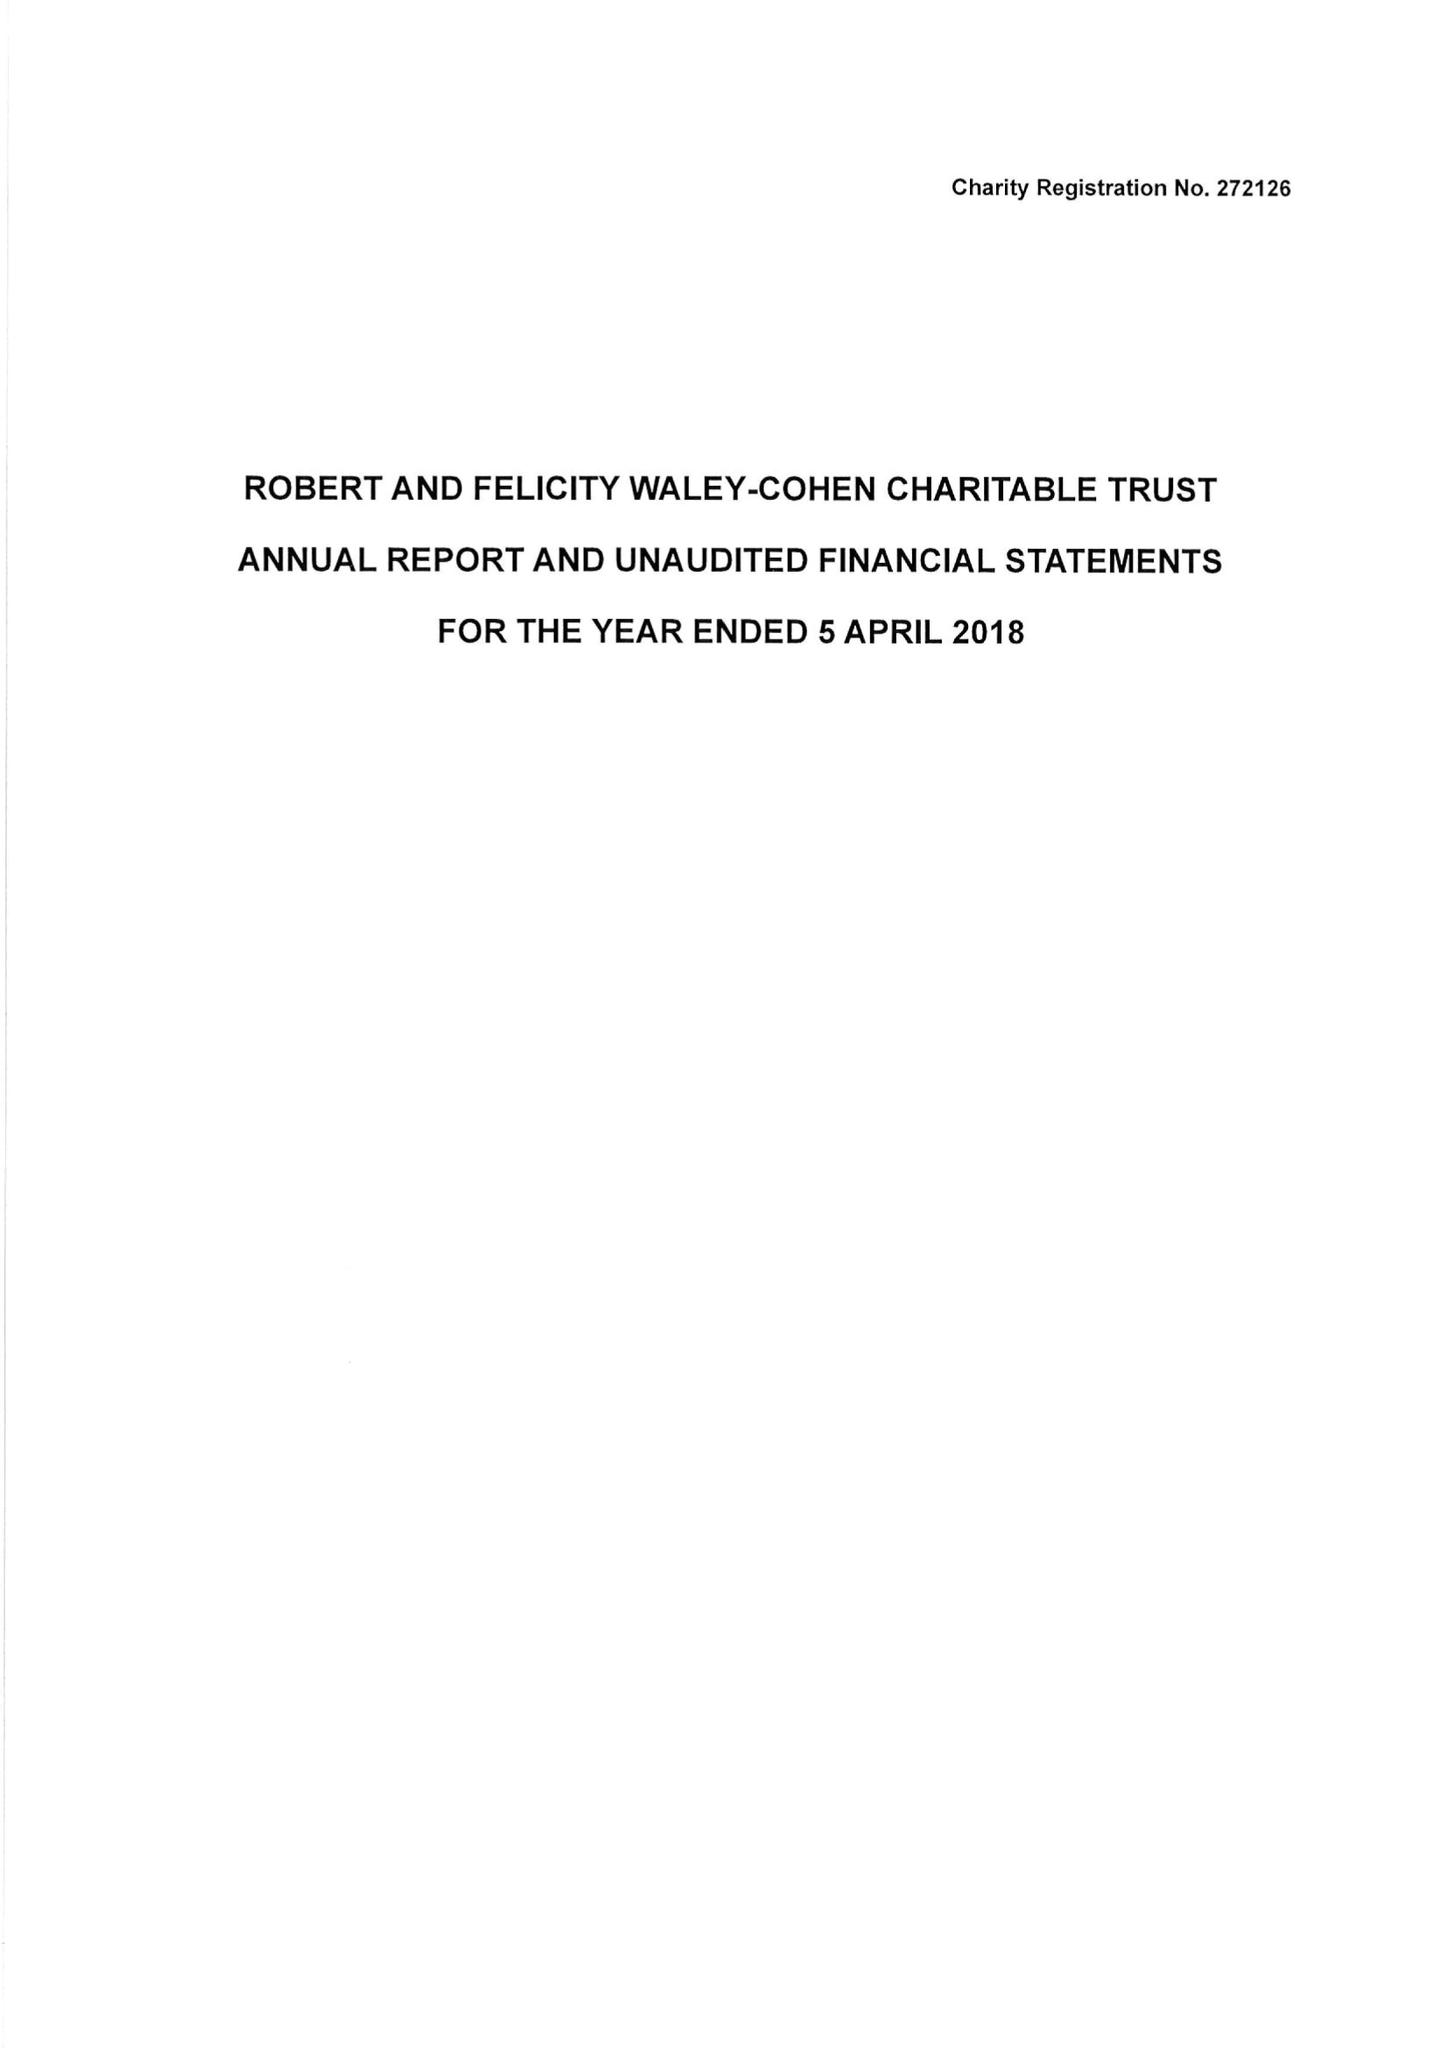What is the value for the charity_name?
Answer the question using a single word or phrase. Robert and Felicity Waley-Cohen Charitable Trust 